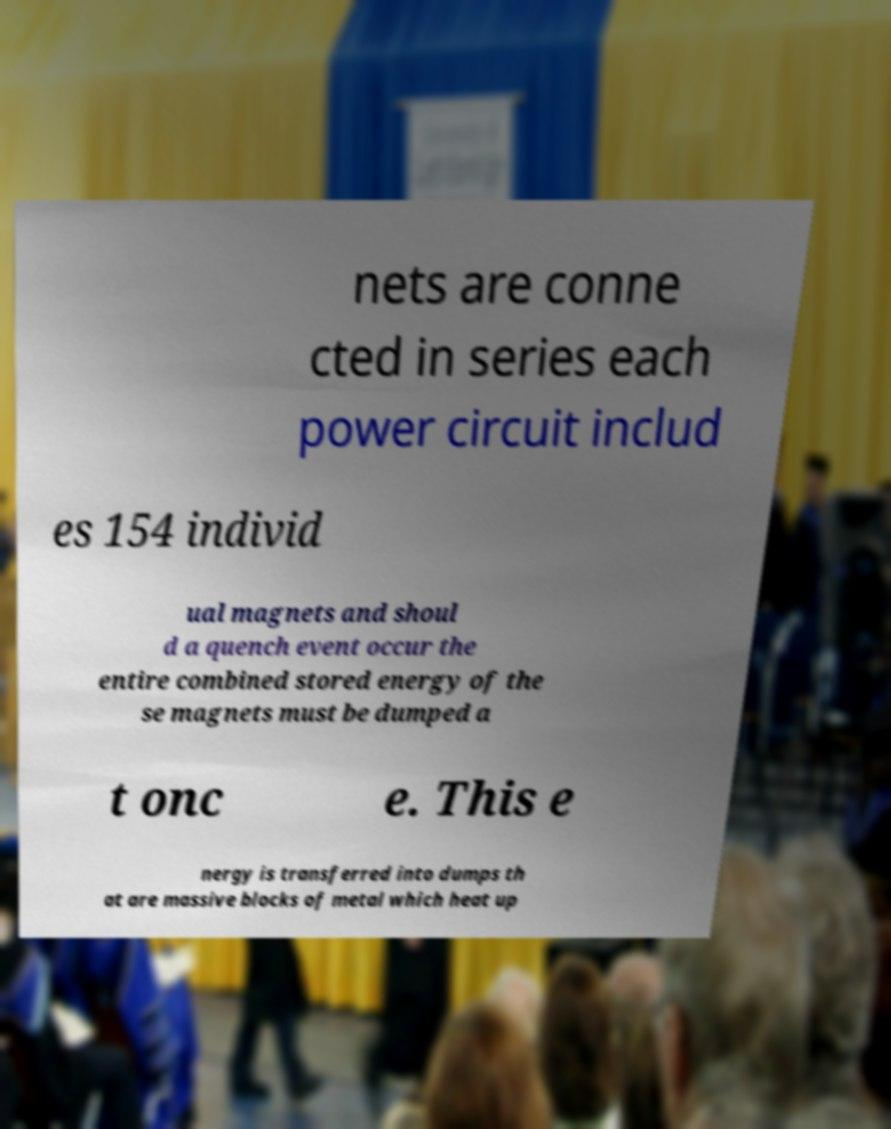Can you accurately transcribe the text from the provided image for me? nets are conne cted in series each power circuit includ es 154 individ ual magnets and shoul d a quench event occur the entire combined stored energy of the se magnets must be dumped a t onc e. This e nergy is transferred into dumps th at are massive blocks of metal which heat up 